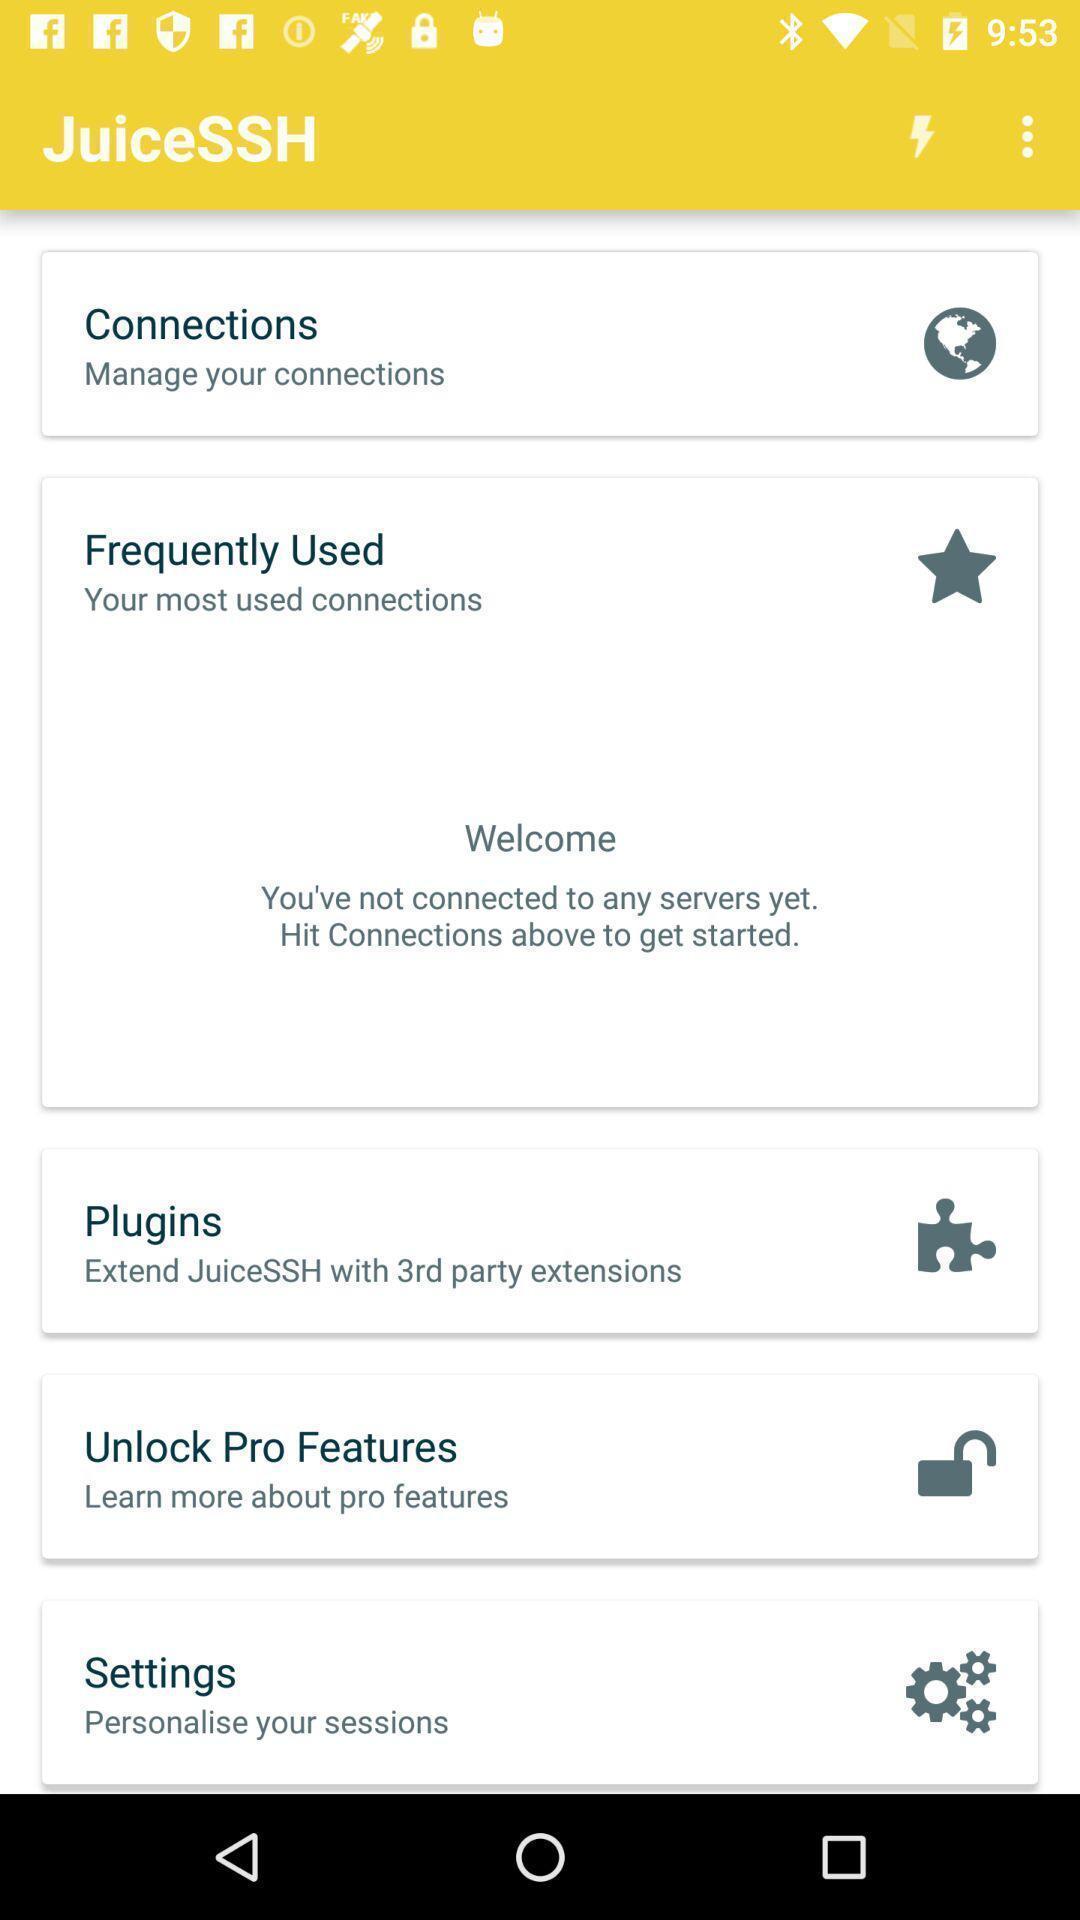Give me a summary of this screen capture. Screen displaying screen page. 